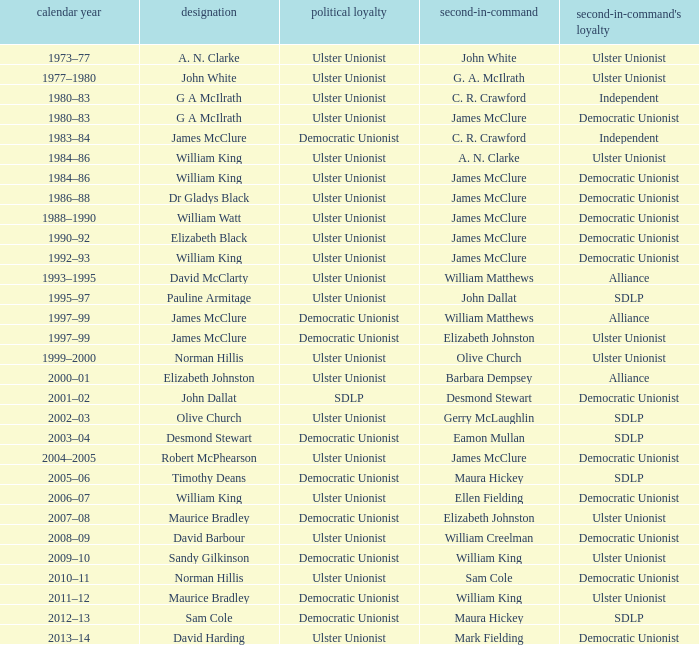What is the Name for 1997–99? James McClure, James McClure. 